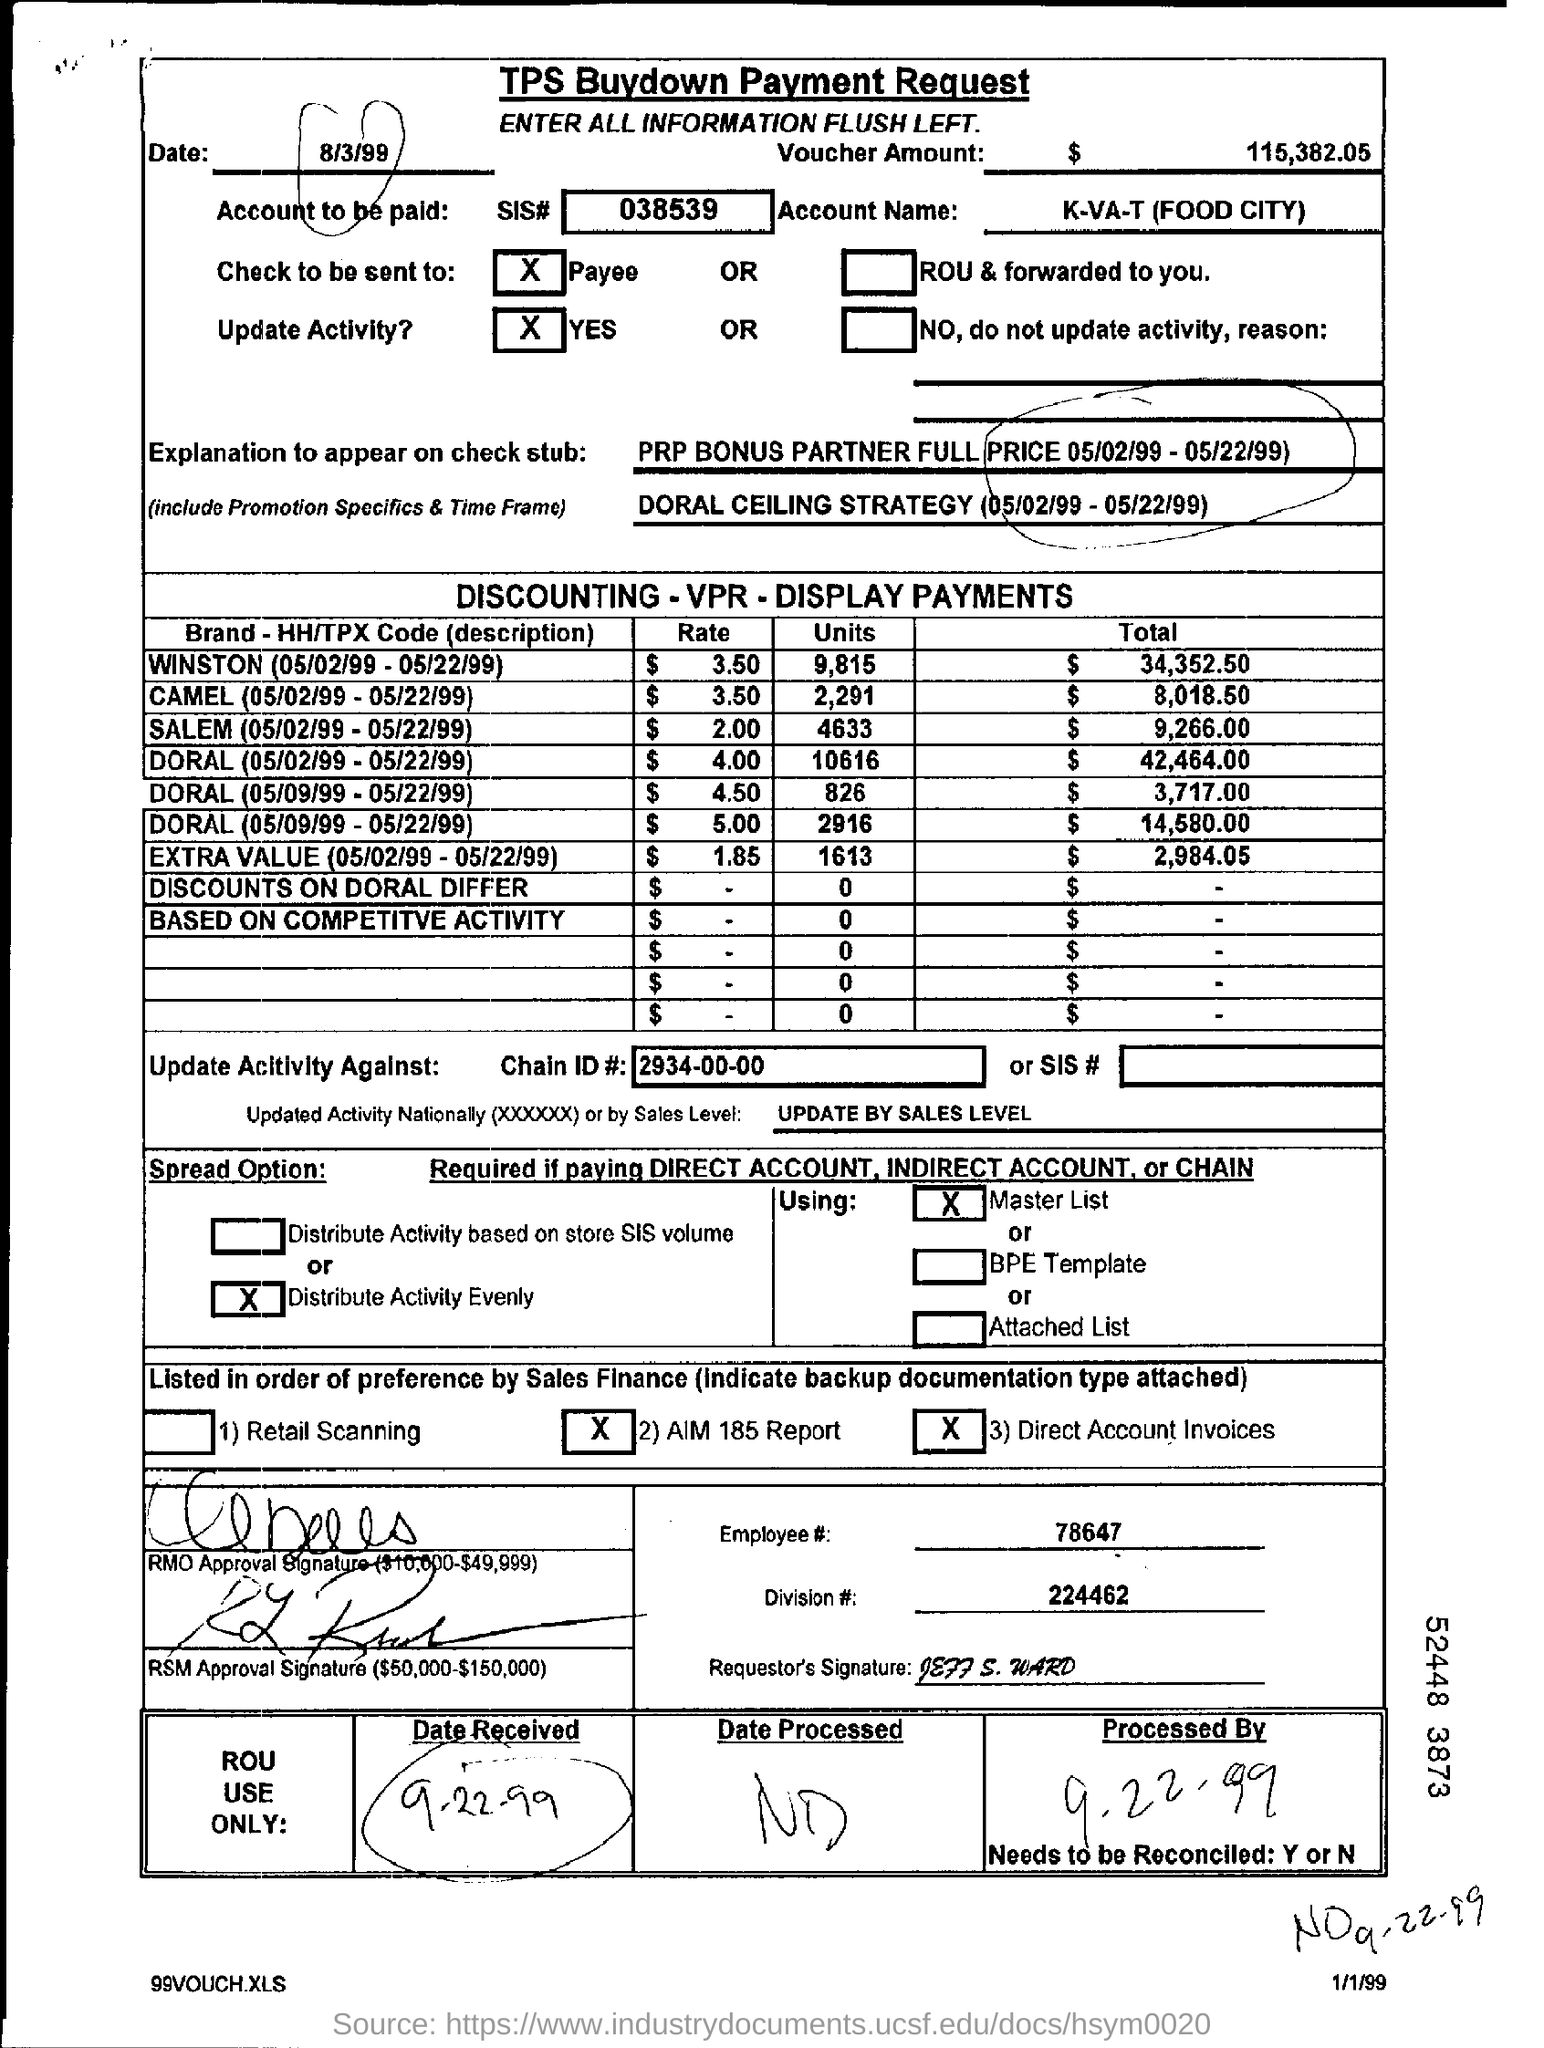Mention a couple of crucial points in this snapshot. The voucher amount is $115,382.05. The total for Winston during the period of May 2nd, 1999 to May 22nd, 1999 was $34,352.50. The SIS number is 038539. The account name is K-VA-T (Food City). The result of the division of 224462 with # is 